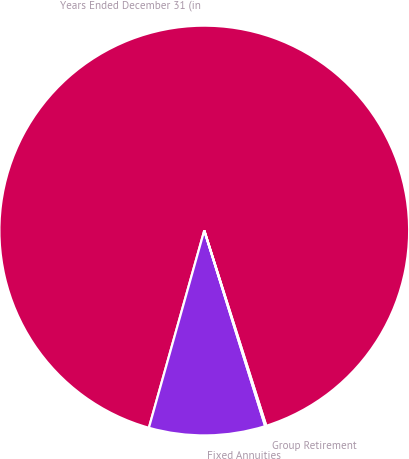<chart> <loc_0><loc_0><loc_500><loc_500><pie_chart><fcel>Years Ended December 31 (in<fcel>Fixed Annuities<fcel>Group Retirement<nl><fcel>90.75%<fcel>9.16%<fcel>0.09%<nl></chart> 